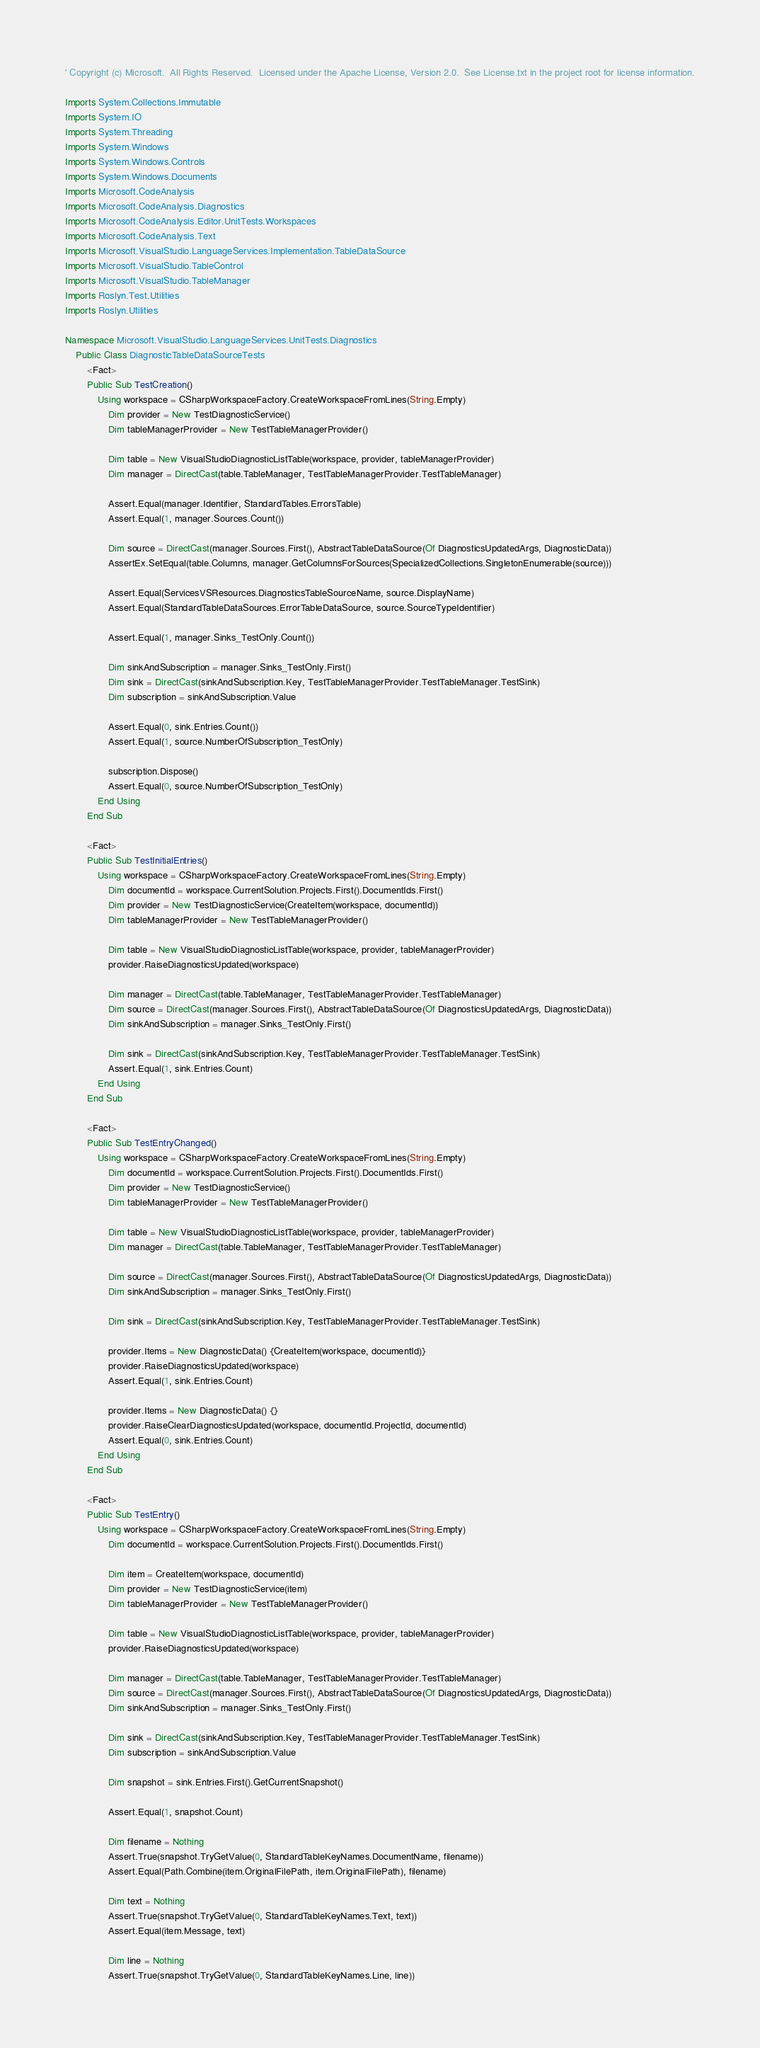<code> <loc_0><loc_0><loc_500><loc_500><_VisualBasic_>' Copyright (c) Microsoft.  All Rights Reserved.  Licensed under the Apache License, Version 2.0.  See License.txt in the project root for license information.

Imports System.Collections.Immutable
Imports System.IO
Imports System.Threading
Imports System.Windows
Imports System.Windows.Controls
Imports System.Windows.Documents
Imports Microsoft.CodeAnalysis
Imports Microsoft.CodeAnalysis.Diagnostics
Imports Microsoft.CodeAnalysis.Editor.UnitTests.Workspaces
Imports Microsoft.CodeAnalysis.Text
Imports Microsoft.VisualStudio.LanguageServices.Implementation.TableDataSource
Imports Microsoft.VisualStudio.TableControl
Imports Microsoft.VisualStudio.TableManager
Imports Roslyn.Test.Utilities
Imports Roslyn.Utilities

Namespace Microsoft.VisualStudio.LanguageServices.UnitTests.Diagnostics
    Public Class DiagnosticTableDataSourceTests
        <Fact>
        Public Sub TestCreation()
            Using workspace = CSharpWorkspaceFactory.CreateWorkspaceFromLines(String.Empty)
                Dim provider = New TestDiagnosticService()
                Dim tableManagerProvider = New TestTableManagerProvider()

                Dim table = New VisualStudioDiagnosticListTable(workspace, provider, tableManagerProvider)
                Dim manager = DirectCast(table.TableManager, TestTableManagerProvider.TestTableManager)

                Assert.Equal(manager.Identifier, StandardTables.ErrorsTable)
                Assert.Equal(1, manager.Sources.Count())

                Dim source = DirectCast(manager.Sources.First(), AbstractTableDataSource(Of DiagnosticsUpdatedArgs, DiagnosticData))
                AssertEx.SetEqual(table.Columns, manager.GetColumnsForSources(SpecializedCollections.SingletonEnumerable(source)))

                Assert.Equal(ServicesVSResources.DiagnosticsTableSourceName, source.DisplayName)
                Assert.Equal(StandardTableDataSources.ErrorTableDataSource, source.SourceTypeIdentifier)

                Assert.Equal(1, manager.Sinks_TestOnly.Count())

                Dim sinkAndSubscription = manager.Sinks_TestOnly.First()
                Dim sink = DirectCast(sinkAndSubscription.Key, TestTableManagerProvider.TestTableManager.TestSink)
                Dim subscription = sinkAndSubscription.Value

                Assert.Equal(0, sink.Entries.Count())
                Assert.Equal(1, source.NumberOfSubscription_TestOnly)

                subscription.Dispose()
                Assert.Equal(0, source.NumberOfSubscription_TestOnly)
            End Using
        End Sub

        <Fact>
        Public Sub TestInitialEntries()
            Using workspace = CSharpWorkspaceFactory.CreateWorkspaceFromLines(String.Empty)
                Dim documentId = workspace.CurrentSolution.Projects.First().DocumentIds.First()
                Dim provider = New TestDiagnosticService(CreateItem(workspace, documentId))
                Dim tableManagerProvider = New TestTableManagerProvider()

                Dim table = New VisualStudioDiagnosticListTable(workspace, provider, tableManagerProvider)
                provider.RaiseDiagnosticsUpdated(workspace)

                Dim manager = DirectCast(table.TableManager, TestTableManagerProvider.TestTableManager)
                Dim source = DirectCast(manager.Sources.First(), AbstractTableDataSource(Of DiagnosticsUpdatedArgs, DiagnosticData))
                Dim sinkAndSubscription = manager.Sinks_TestOnly.First()

                Dim sink = DirectCast(sinkAndSubscription.Key, TestTableManagerProvider.TestTableManager.TestSink)
                Assert.Equal(1, sink.Entries.Count)
            End Using
        End Sub

        <Fact>
        Public Sub TestEntryChanged()
            Using workspace = CSharpWorkspaceFactory.CreateWorkspaceFromLines(String.Empty)
                Dim documentId = workspace.CurrentSolution.Projects.First().DocumentIds.First()
                Dim provider = New TestDiagnosticService()
                Dim tableManagerProvider = New TestTableManagerProvider()

                Dim table = New VisualStudioDiagnosticListTable(workspace, provider, tableManagerProvider)
                Dim manager = DirectCast(table.TableManager, TestTableManagerProvider.TestTableManager)

                Dim source = DirectCast(manager.Sources.First(), AbstractTableDataSource(Of DiagnosticsUpdatedArgs, DiagnosticData))
                Dim sinkAndSubscription = manager.Sinks_TestOnly.First()

                Dim sink = DirectCast(sinkAndSubscription.Key, TestTableManagerProvider.TestTableManager.TestSink)

                provider.Items = New DiagnosticData() {CreateItem(workspace, documentId)}
                provider.RaiseDiagnosticsUpdated(workspace)
                Assert.Equal(1, sink.Entries.Count)

                provider.Items = New DiagnosticData() {}
                provider.RaiseClearDiagnosticsUpdated(workspace, documentId.ProjectId, documentId)
                Assert.Equal(0, sink.Entries.Count)
            End Using
        End Sub

        <Fact>
        Public Sub TestEntry()
            Using workspace = CSharpWorkspaceFactory.CreateWorkspaceFromLines(String.Empty)
                Dim documentId = workspace.CurrentSolution.Projects.First().DocumentIds.First()

                Dim item = CreateItem(workspace, documentId)
                Dim provider = New TestDiagnosticService(item)
                Dim tableManagerProvider = New TestTableManagerProvider()

                Dim table = New VisualStudioDiagnosticListTable(workspace, provider, tableManagerProvider)
                provider.RaiseDiagnosticsUpdated(workspace)

                Dim manager = DirectCast(table.TableManager, TestTableManagerProvider.TestTableManager)
                Dim source = DirectCast(manager.Sources.First(), AbstractTableDataSource(Of DiagnosticsUpdatedArgs, DiagnosticData))
                Dim sinkAndSubscription = manager.Sinks_TestOnly.First()

                Dim sink = DirectCast(sinkAndSubscription.Key, TestTableManagerProvider.TestTableManager.TestSink)
                Dim subscription = sinkAndSubscription.Value

                Dim snapshot = sink.Entries.First().GetCurrentSnapshot()

                Assert.Equal(1, snapshot.Count)

                Dim filename = Nothing
                Assert.True(snapshot.TryGetValue(0, StandardTableKeyNames.DocumentName, filename))
                Assert.Equal(Path.Combine(item.OriginalFilePath, item.OriginalFilePath), filename)

                Dim text = Nothing
                Assert.True(snapshot.TryGetValue(0, StandardTableKeyNames.Text, text))
                Assert.Equal(item.Message, text)

                Dim line = Nothing
                Assert.True(snapshot.TryGetValue(0, StandardTableKeyNames.Line, line))</code> 